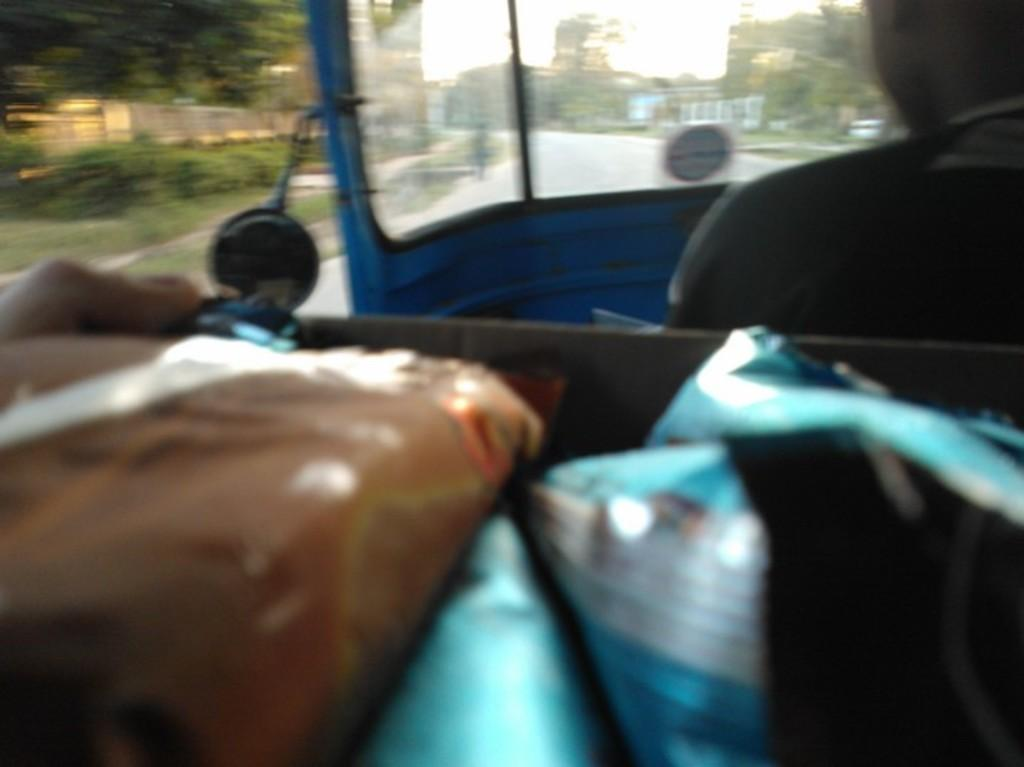What is present in the image that is being transported? There are packets in the image that are being transported. Where are the packets located? The packets are in an auto. Is there anyone present in the auto with the packets? Yes, there is a person sitting in the auto. What type of boat can be seen in the image? There is no boat present in the image; it features packets in an auto with a person sitting inside. What is the weather like in the image? The provided facts do not mention the weather, so we cannot determine the weather from the image. 